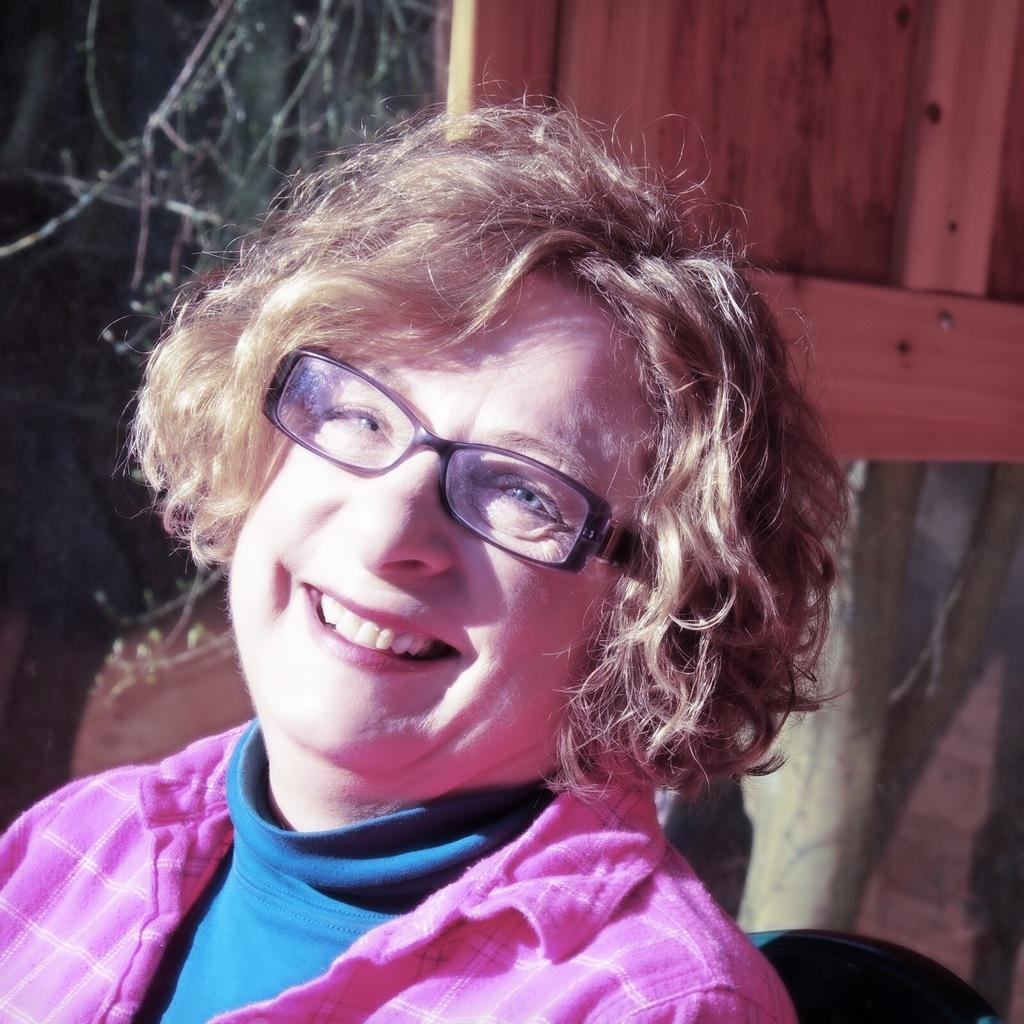Who is present in the image? There is a woman in the image. What accessory is the woman wearing? The woman is wearing specs. What can be seen in the background of the image? There is a wooden object in the background of the image. What type of plant is visible in the image? There is a tree in the image. How many cattle can be seen grazing near the tree in the image? There are no cattle present in the image; it only features a woman, specs, a wooden object, and a tree. 